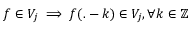<formula> <loc_0><loc_0><loc_500><loc_500>f \in V _ { j } \implies f ( . - k ) \in V _ { j } , \forall k \in \mathbb { Z }</formula> 